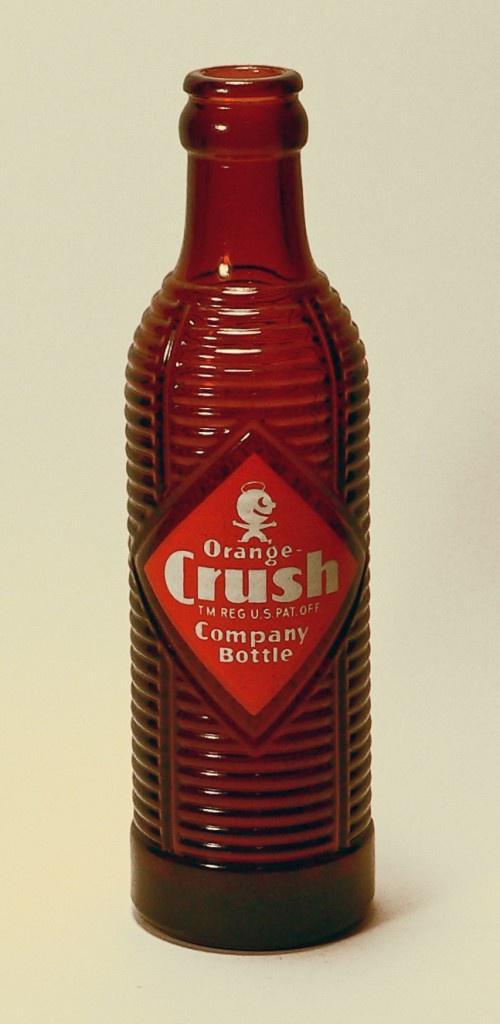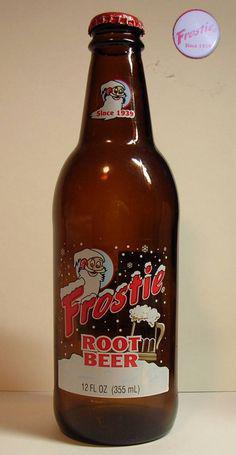The first image is the image on the left, the second image is the image on the right. Evaluate the accuracy of this statement regarding the images: "there is an amber colored empty bottle with no cap on". Is it true? Answer yes or no. Yes. The first image is the image on the left, the second image is the image on the right. For the images displayed, is the sentence "One bottle is capped and one is not, at least one bottle is brown glass, at least one bottle is empty, and all bottles are beverage bottles." factually correct? Answer yes or no. Yes. 